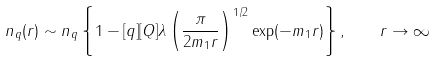<formula> <loc_0><loc_0><loc_500><loc_500>n _ { q } ( r ) \sim n _ { q } \left \{ 1 - [ q ] [ Q ] \lambda \left ( \frac { \pi } { 2 m _ { 1 } r } \right ) ^ { 1 / 2 } \exp ( - m _ { 1 } r ) \right \} , \quad r \to \infty</formula> 